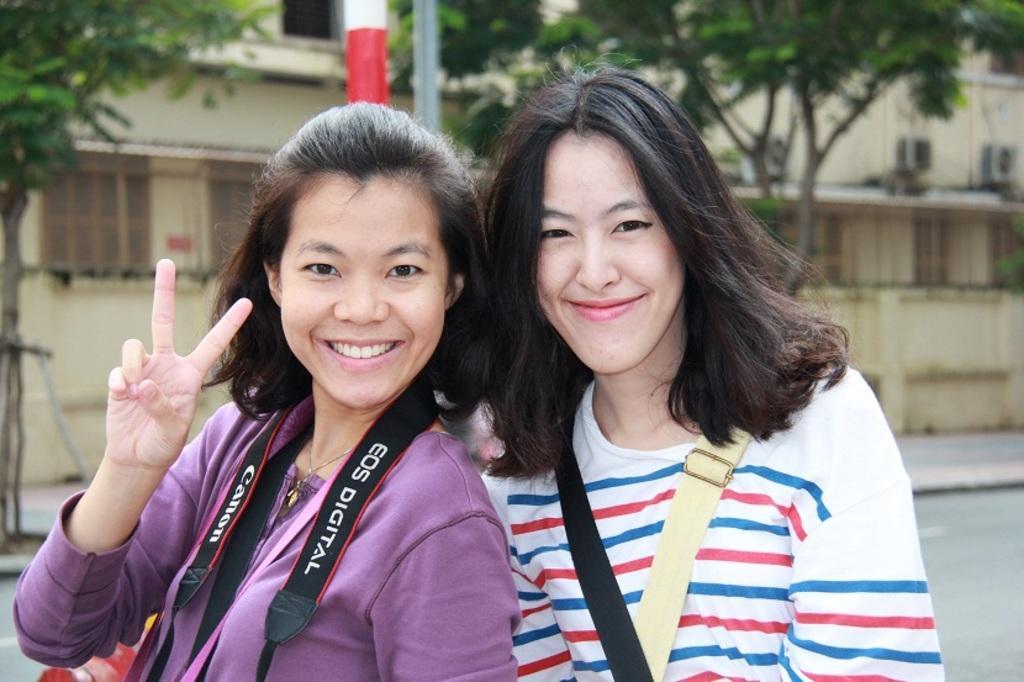Describe this image in one or two sentences. This image consists of two women. They are smiling. There are trees at the top. There is a building in the middle. 